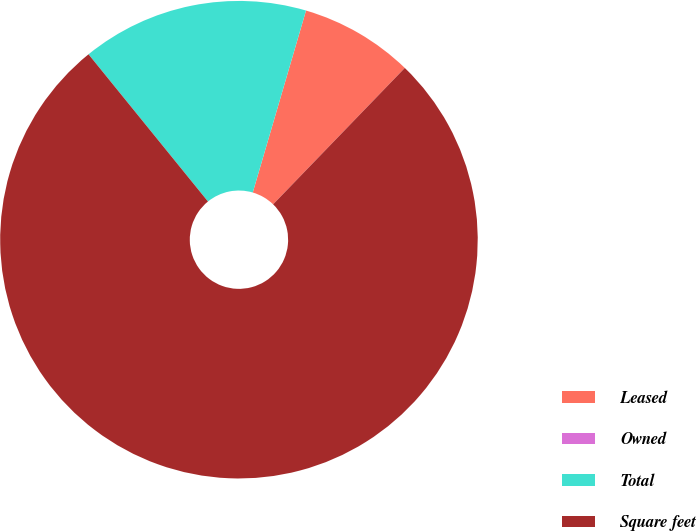Convert chart. <chart><loc_0><loc_0><loc_500><loc_500><pie_chart><fcel>Leased<fcel>Owned<fcel>Total<fcel>Square feet<nl><fcel>7.69%<fcel>0.0%<fcel>15.38%<fcel>76.92%<nl></chart> 